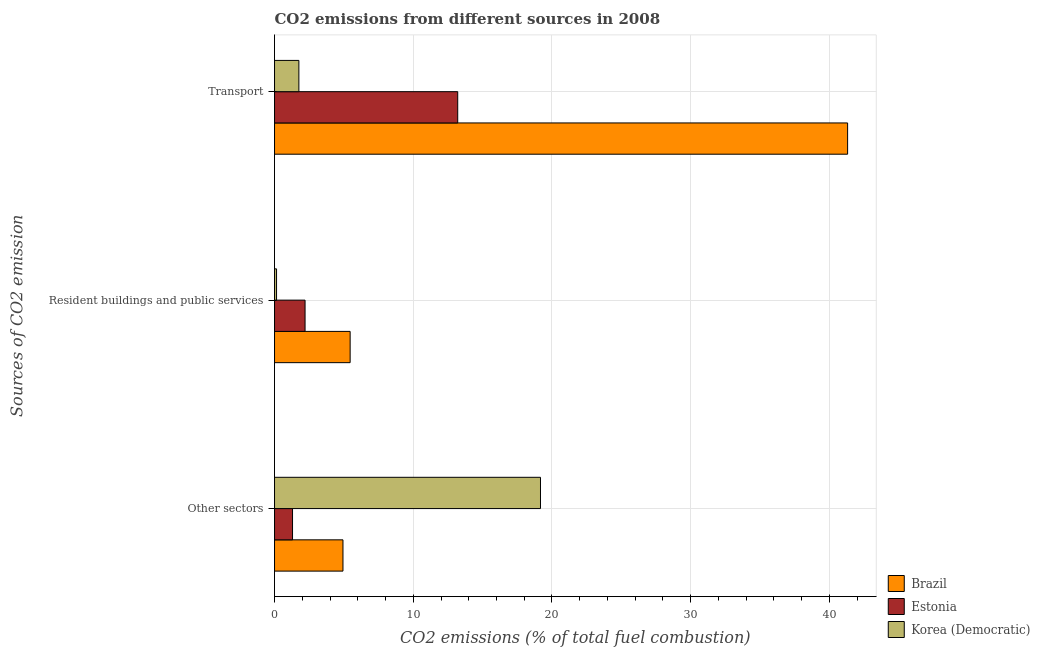How many groups of bars are there?
Make the answer very short. 3. Are the number of bars per tick equal to the number of legend labels?
Make the answer very short. Yes. How many bars are there on the 1st tick from the top?
Offer a very short reply. 3. What is the label of the 1st group of bars from the top?
Ensure brevity in your answer.  Transport. What is the percentage of co2 emissions from resident buildings and public services in Estonia?
Your answer should be very brief. 2.2. Across all countries, what is the maximum percentage of co2 emissions from other sectors?
Provide a succinct answer. 19.17. Across all countries, what is the minimum percentage of co2 emissions from resident buildings and public services?
Give a very brief answer. 0.15. In which country was the percentage of co2 emissions from transport minimum?
Ensure brevity in your answer.  Korea (Democratic). What is the total percentage of co2 emissions from other sectors in the graph?
Offer a terse response. 25.4. What is the difference between the percentage of co2 emissions from transport in Korea (Democratic) and that in Estonia?
Make the answer very short. -11.45. What is the difference between the percentage of co2 emissions from transport in Brazil and the percentage of co2 emissions from resident buildings and public services in Korea (Democratic)?
Give a very brief answer. 41.16. What is the average percentage of co2 emissions from resident buildings and public services per country?
Offer a very short reply. 2.6. What is the difference between the percentage of co2 emissions from resident buildings and public services and percentage of co2 emissions from transport in Estonia?
Offer a very short reply. -11. What is the ratio of the percentage of co2 emissions from transport in Brazil to that in Estonia?
Offer a terse response. 3.13. Is the difference between the percentage of co2 emissions from other sectors in Korea (Democratic) and Brazil greater than the difference between the percentage of co2 emissions from transport in Korea (Democratic) and Brazil?
Your answer should be very brief. Yes. What is the difference between the highest and the second highest percentage of co2 emissions from transport?
Your answer should be compact. 28.1. What is the difference between the highest and the lowest percentage of co2 emissions from resident buildings and public services?
Your answer should be compact. 5.31. In how many countries, is the percentage of co2 emissions from resident buildings and public services greater than the average percentage of co2 emissions from resident buildings and public services taken over all countries?
Provide a short and direct response. 1. What does the 3rd bar from the top in Resident buildings and public services represents?
Keep it short and to the point. Brazil. What does the 3rd bar from the bottom in Transport represents?
Make the answer very short. Korea (Democratic). Is it the case that in every country, the sum of the percentage of co2 emissions from other sectors and percentage of co2 emissions from resident buildings and public services is greater than the percentage of co2 emissions from transport?
Offer a terse response. No. Are all the bars in the graph horizontal?
Give a very brief answer. Yes. Are the values on the major ticks of X-axis written in scientific E-notation?
Keep it short and to the point. No. Does the graph contain any zero values?
Offer a very short reply. No. Does the graph contain grids?
Your answer should be compact. Yes. What is the title of the graph?
Your answer should be compact. CO2 emissions from different sources in 2008. Does "Mexico" appear as one of the legend labels in the graph?
Offer a very short reply. No. What is the label or title of the X-axis?
Your answer should be very brief. CO2 emissions (% of total fuel combustion). What is the label or title of the Y-axis?
Provide a short and direct response. Sources of CO2 emission. What is the CO2 emissions (% of total fuel combustion) in Brazil in Other sectors?
Ensure brevity in your answer.  4.93. What is the CO2 emissions (% of total fuel combustion) in Estonia in Other sectors?
Keep it short and to the point. 1.3. What is the CO2 emissions (% of total fuel combustion) in Korea (Democratic) in Other sectors?
Ensure brevity in your answer.  19.17. What is the CO2 emissions (% of total fuel combustion) in Brazil in Resident buildings and public services?
Offer a very short reply. 5.45. What is the CO2 emissions (% of total fuel combustion) of Estonia in Resident buildings and public services?
Make the answer very short. 2.2. What is the CO2 emissions (% of total fuel combustion) in Korea (Democratic) in Resident buildings and public services?
Provide a short and direct response. 0.15. What is the CO2 emissions (% of total fuel combustion) of Brazil in Transport?
Provide a succinct answer. 41.31. What is the CO2 emissions (% of total fuel combustion) of Estonia in Transport?
Your answer should be compact. 13.21. What is the CO2 emissions (% of total fuel combustion) in Korea (Democratic) in Transport?
Ensure brevity in your answer.  1.75. Across all Sources of CO2 emission, what is the maximum CO2 emissions (% of total fuel combustion) in Brazil?
Give a very brief answer. 41.31. Across all Sources of CO2 emission, what is the maximum CO2 emissions (% of total fuel combustion) in Estonia?
Your response must be concise. 13.21. Across all Sources of CO2 emission, what is the maximum CO2 emissions (% of total fuel combustion) in Korea (Democratic)?
Ensure brevity in your answer.  19.17. Across all Sources of CO2 emission, what is the minimum CO2 emissions (% of total fuel combustion) of Brazil?
Make the answer very short. 4.93. Across all Sources of CO2 emission, what is the minimum CO2 emissions (% of total fuel combustion) of Estonia?
Ensure brevity in your answer.  1.3. Across all Sources of CO2 emission, what is the minimum CO2 emissions (% of total fuel combustion) of Korea (Democratic)?
Provide a short and direct response. 0.15. What is the total CO2 emissions (% of total fuel combustion) in Brazil in the graph?
Provide a succinct answer. 51.69. What is the total CO2 emissions (% of total fuel combustion) of Estonia in the graph?
Offer a terse response. 16.7. What is the total CO2 emissions (% of total fuel combustion) of Korea (Democratic) in the graph?
Provide a short and direct response. 21.07. What is the difference between the CO2 emissions (% of total fuel combustion) of Brazil in Other sectors and that in Resident buildings and public services?
Offer a very short reply. -0.52. What is the difference between the CO2 emissions (% of total fuel combustion) in Estonia in Other sectors and that in Resident buildings and public services?
Give a very brief answer. -0.9. What is the difference between the CO2 emissions (% of total fuel combustion) of Korea (Democratic) in Other sectors and that in Resident buildings and public services?
Ensure brevity in your answer.  19.03. What is the difference between the CO2 emissions (% of total fuel combustion) of Brazil in Other sectors and that in Transport?
Provide a short and direct response. -36.38. What is the difference between the CO2 emissions (% of total fuel combustion) of Estonia in Other sectors and that in Transport?
Offer a terse response. -11.91. What is the difference between the CO2 emissions (% of total fuel combustion) of Korea (Democratic) in Other sectors and that in Transport?
Keep it short and to the point. 17.42. What is the difference between the CO2 emissions (% of total fuel combustion) in Brazil in Resident buildings and public services and that in Transport?
Provide a succinct answer. -35.86. What is the difference between the CO2 emissions (% of total fuel combustion) in Estonia in Resident buildings and public services and that in Transport?
Give a very brief answer. -11. What is the difference between the CO2 emissions (% of total fuel combustion) of Korea (Democratic) in Resident buildings and public services and that in Transport?
Your answer should be compact. -1.61. What is the difference between the CO2 emissions (% of total fuel combustion) of Brazil in Other sectors and the CO2 emissions (% of total fuel combustion) of Estonia in Resident buildings and public services?
Your answer should be very brief. 2.73. What is the difference between the CO2 emissions (% of total fuel combustion) of Brazil in Other sectors and the CO2 emissions (% of total fuel combustion) of Korea (Democratic) in Resident buildings and public services?
Your answer should be compact. 4.79. What is the difference between the CO2 emissions (% of total fuel combustion) in Estonia in Other sectors and the CO2 emissions (% of total fuel combustion) in Korea (Democratic) in Resident buildings and public services?
Make the answer very short. 1.15. What is the difference between the CO2 emissions (% of total fuel combustion) of Brazil in Other sectors and the CO2 emissions (% of total fuel combustion) of Estonia in Transport?
Make the answer very short. -8.27. What is the difference between the CO2 emissions (% of total fuel combustion) in Brazil in Other sectors and the CO2 emissions (% of total fuel combustion) in Korea (Democratic) in Transport?
Your answer should be very brief. 3.18. What is the difference between the CO2 emissions (% of total fuel combustion) of Estonia in Other sectors and the CO2 emissions (% of total fuel combustion) of Korea (Democratic) in Transport?
Your answer should be compact. -0.46. What is the difference between the CO2 emissions (% of total fuel combustion) of Brazil in Resident buildings and public services and the CO2 emissions (% of total fuel combustion) of Estonia in Transport?
Keep it short and to the point. -7.76. What is the difference between the CO2 emissions (% of total fuel combustion) in Brazil in Resident buildings and public services and the CO2 emissions (% of total fuel combustion) in Korea (Democratic) in Transport?
Your answer should be very brief. 3.7. What is the difference between the CO2 emissions (% of total fuel combustion) in Estonia in Resident buildings and public services and the CO2 emissions (% of total fuel combustion) in Korea (Democratic) in Transport?
Make the answer very short. 0.45. What is the average CO2 emissions (% of total fuel combustion) of Brazil per Sources of CO2 emission?
Your response must be concise. 17.23. What is the average CO2 emissions (% of total fuel combustion) of Estonia per Sources of CO2 emission?
Offer a very short reply. 5.57. What is the average CO2 emissions (% of total fuel combustion) of Korea (Democratic) per Sources of CO2 emission?
Make the answer very short. 7.02. What is the difference between the CO2 emissions (% of total fuel combustion) in Brazil and CO2 emissions (% of total fuel combustion) in Estonia in Other sectors?
Ensure brevity in your answer.  3.64. What is the difference between the CO2 emissions (% of total fuel combustion) of Brazil and CO2 emissions (% of total fuel combustion) of Korea (Democratic) in Other sectors?
Provide a short and direct response. -14.24. What is the difference between the CO2 emissions (% of total fuel combustion) in Estonia and CO2 emissions (% of total fuel combustion) in Korea (Democratic) in Other sectors?
Offer a very short reply. -17.87. What is the difference between the CO2 emissions (% of total fuel combustion) of Brazil and CO2 emissions (% of total fuel combustion) of Estonia in Resident buildings and public services?
Offer a terse response. 3.25. What is the difference between the CO2 emissions (% of total fuel combustion) of Brazil and CO2 emissions (% of total fuel combustion) of Korea (Democratic) in Resident buildings and public services?
Provide a succinct answer. 5.31. What is the difference between the CO2 emissions (% of total fuel combustion) in Estonia and CO2 emissions (% of total fuel combustion) in Korea (Democratic) in Resident buildings and public services?
Give a very brief answer. 2.06. What is the difference between the CO2 emissions (% of total fuel combustion) in Brazil and CO2 emissions (% of total fuel combustion) in Estonia in Transport?
Your response must be concise. 28.1. What is the difference between the CO2 emissions (% of total fuel combustion) of Brazil and CO2 emissions (% of total fuel combustion) of Korea (Democratic) in Transport?
Offer a terse response. 39.55. What is the difference between the CO2 emissions (% of total fuel combustion) in Estonia and CO2 emissions (% of total fuel combustion) in Korea (Democratic) in Transport?
Make the answer very short. 11.45. What is the ratio of the CO2 emissions (% of total fuel combustion) of Brazil in Other sectors to that in Resident buildings and public services?
Keep it short and to the point. 0.91. What is the ratio of the CO2 emissions (% of total fuel combustion) of Estonia in Other sectors to that in Resident buildings and public services?
Ensure brevity in your answer.  0.59. What is the ratio of the CO2 emissions (% of total fuel combustion) in Korea (Democratic) in Other sectors to that in Resident buildings and public services?
Ensure brevity in your answer.  132.2. What is the ratio of the CO2 emissions (% of total fuel combustion) in Brazil in Other sectors to that in Transport?
Provide a succinct answer. 0.12. What is the ratio of the CO2 emissions (% of total fuel combustion) of Estonia in Other sectors to that in Transport?
Your answer should be very brief. 0.1. What is the ratio of the CO2 emissions (% of total fuel combustion) in Korea (Democratic) in Other sectors to that in Transport?
Make the answer very short. 10.93. What is the ratio of the CO2 emissions (% of total fuel combustion) in Brazil in Resident buildings and public services to that in Transport?
Your answer should be very brief. 0.13. What is the ratio of the CO2 emissions (% of total fuel combustion) of Korea (Democratic) in Resident buildings and public services to that in Transport?
Offer a terse response. 0.08. What is the difference between the highest and the second highest CO2 emissions (% of total fuel combustion) in Brazil?
Your answer should be compact. 35.86. What is the difference between the highest and the second highest CO2 emissions (% of total fuel combustion) in Estonia?
Give a very brief answer. 11. What is the difference between the highest and the second highest CO2 emissions (% of total fuel combustion) in Korea (Democratic)?
Ensure brevity in your answer.  17.42. What is the difference between the highest and the lowest CO2 emissions (% of total fuel combustion) of Brazil?
Your answer should be compact. 36.38. What is the difference between the highest and the lowest CO2 emissions (% of total fuel combustion) of Estonia?
Give a very brief answer. 11.91. What is the difference between the highest and the lowest CO2 emissions (% of total fuel combustion) of Korea (Democratic)?
Offer a terse response. 19.03. 